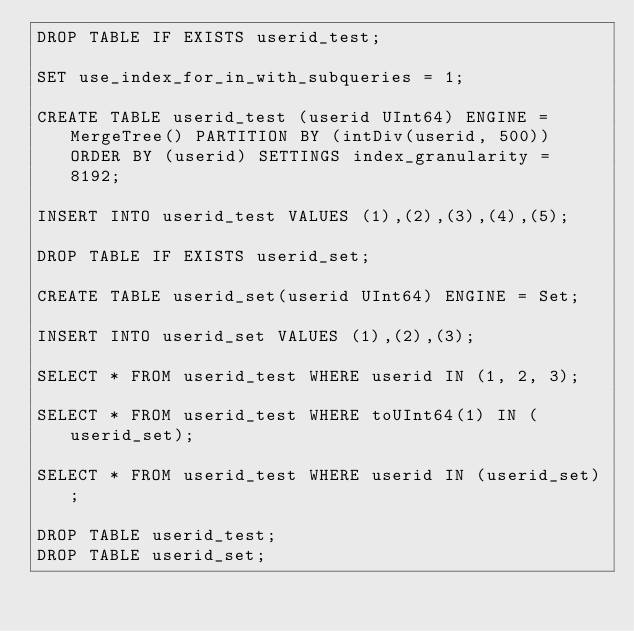<code> <loc_0><loc_0><loc_500><loc_500><_SQL_>DROP TABLE IF EXISTS userid_test;

SET use_index_for_in_with_subqueries = 1;

CREATE TABLE userid_test (userid UInt64) ENGINE = MergeTree() PARTITION BY (intDiv(userid, 500)) ORDER BY (userid) SETTINGS index_granularity = 8192;

INSERT INTO userid_test VALUES (1),(2),(3),(4),(5);

DROP TABLE IF EXISTS userid_set;

CREATE TABLE userid_set(userid UInt64) ENGINE = Set;

INSERT INTO userid_set VALUES (1),(2),(3);

SELECT * FROM userid_test WHERE userid IN (1, 2, 3);

SELECT * FROM userid_test WHERE toUInt64(1) IN (userid_set);

SELECT * FROM userid_test WHERE userid IN (userid_set);

DROP TABLE userid_test;
DROP TABLE userid_set;
</code> 